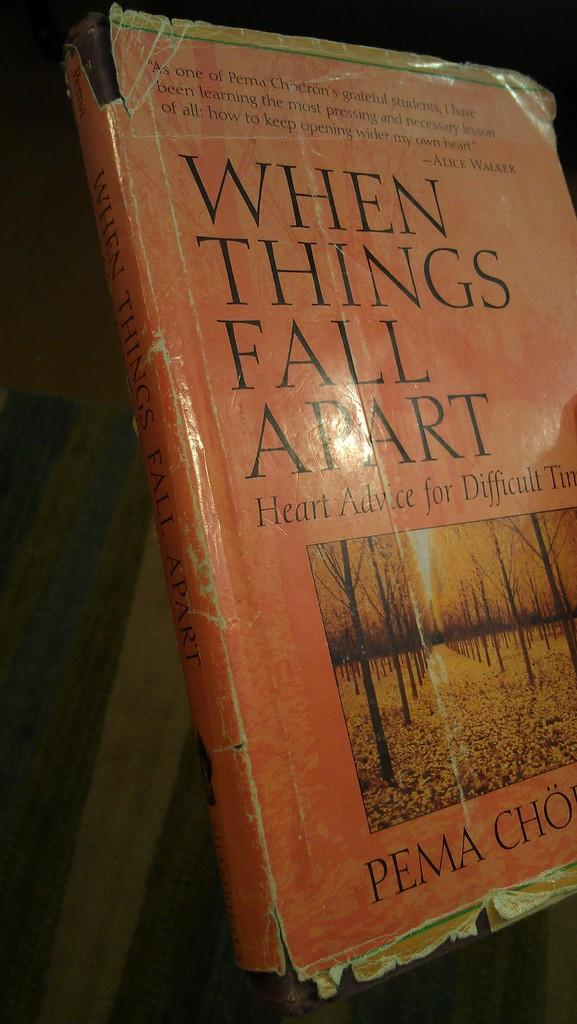Provide a one-sentence caption for the provided image. A book with an orange cover talking about things falling apart. 